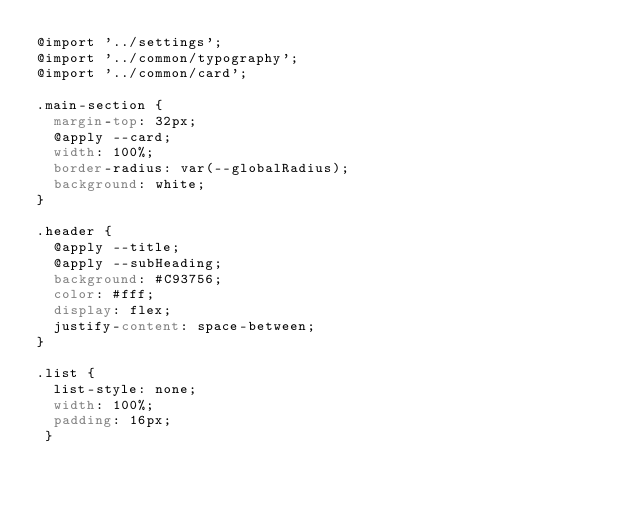Convert code to text. <code><loc_0><loc_0><loc_500><loc_500><_CSS_>@import '../settings';
@import '../common/typography';
@import '../common/card';

.main-section {
  margin-top: 32px;
  @apply --card;
  width: 100%;
  border-radius: var(--globalRadius);
  background: white;
}

.header {
  @apply --title;
  @apply --subHeading;
  background: #C93756;
  color: #fff;
  display: flex;
  justify-content: space-between;
}

.list {
  list-style: none;
  width: 100%;
  padding: 16px;
 }

</code> 